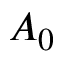Convert formula to latex. <formula><loc_0><loc_0><loc_500><loc_500>A _ { 0 }</formula> 